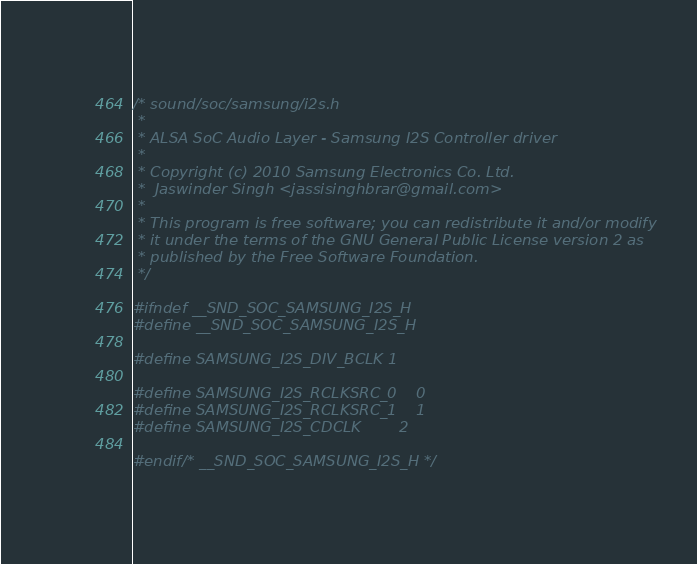Convert code to text. <code><loc_0><loc_0><loc_500><loc_500><_C_>/* sound/soc/samsung/i2s.h
 *
 * ALSA SoC Audio Layer - Samsung I2S Controller driver
 *
 * Copyright (c) 2010 Samsung Electronics Co. Ltd.
 *	Jaswinder Singh <jassisinghbrar@gmail.com>
 *
 * This program is free software; you can redistribute it and/or modify
 * it under the terms of the GNU General Public License version 2 as
 * published by the Free Software Foundation.
 */

#ifndef __SND_SOC_SAMSUNG_I2S_H
#define __SND_SOC_SAMSUNG_I2S_H

#define SAMSUNG_I2S_DIV_BCLK	1

#define SAMSUNG_I2S_RCLKSRC_0	0
#define SAMSUNG_I2S_RCLKSRC_1	1
#define SAMSUNG_I2S_CDCLK		2

#endif /* __SND_SOC_SAMSUNG_I2S_H */
</code> 